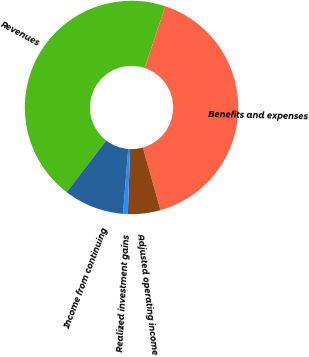Convert chart. <chart><loc_0><loc_0><loc_500><loc_500><pie_chart><fcel>Revenues<fcel>Benefits and expenses<fcel>Adjusted operating income<fcel>Realized investment gains<fcel>Income from continuing<nl><fcel>44.71%<fcel>40.5%<fcel>4.93%<fcel>0.72%<fcel>9.14%<nl></chart> 